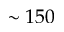Convert formula to latex. <formula><loc_0><loc_0><loc_500><loc_500>\sim 1 5 0</formula> 